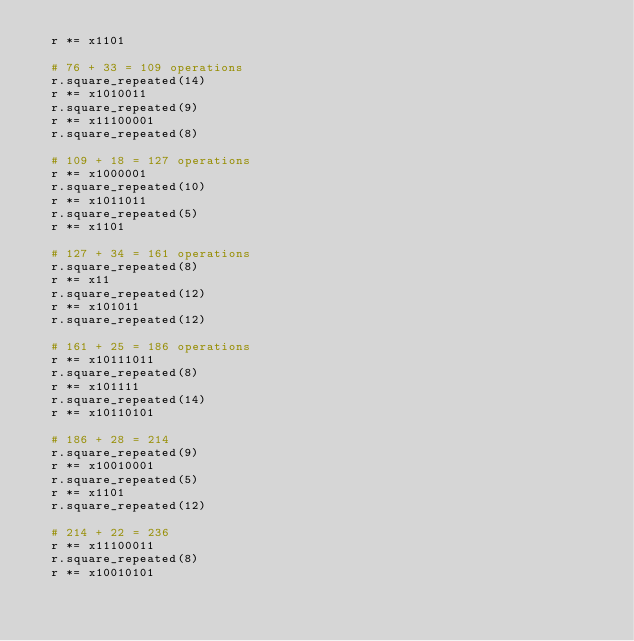<code> <loc_0><loc_0><loc_500><loc_500><_Nim_>  r *= x1101

  # 76 + 33 = 109 operations
  r.square_repeated(14)
  r *= x1010011
  r.square_repeated(9)
  r *= x11100001
  r.square_repeated(8)

  # 109 + 18 = 127 operations
  r *= x1000001
  r.square_repeated(10)
  r *= x1011011
  r.square_repeated(5)
  r *= x1101

  # 127 + 34 = 161 operations
  r.square_repeated(8)
  r *= x11
  r.square_repeated(12)
  r *= x101011
  r.square_repeated(12)

  # 161 + 25 = 186 operations
  r *= x10111011
  r.square_repeated(8)
  r *= x101111
  r.square_repeated(14)
  r *= x10110101

  # 186 + 28 = 214
  r.square_repeated(9)
  r *= x10010001
  r.square_repeated(5)
  r *= x1101
  r.square_repeated(12)

  # 214 + 22 = 236
  r *= x11100011
  r.square_repeated(8)
  r *= x10010101</code> 